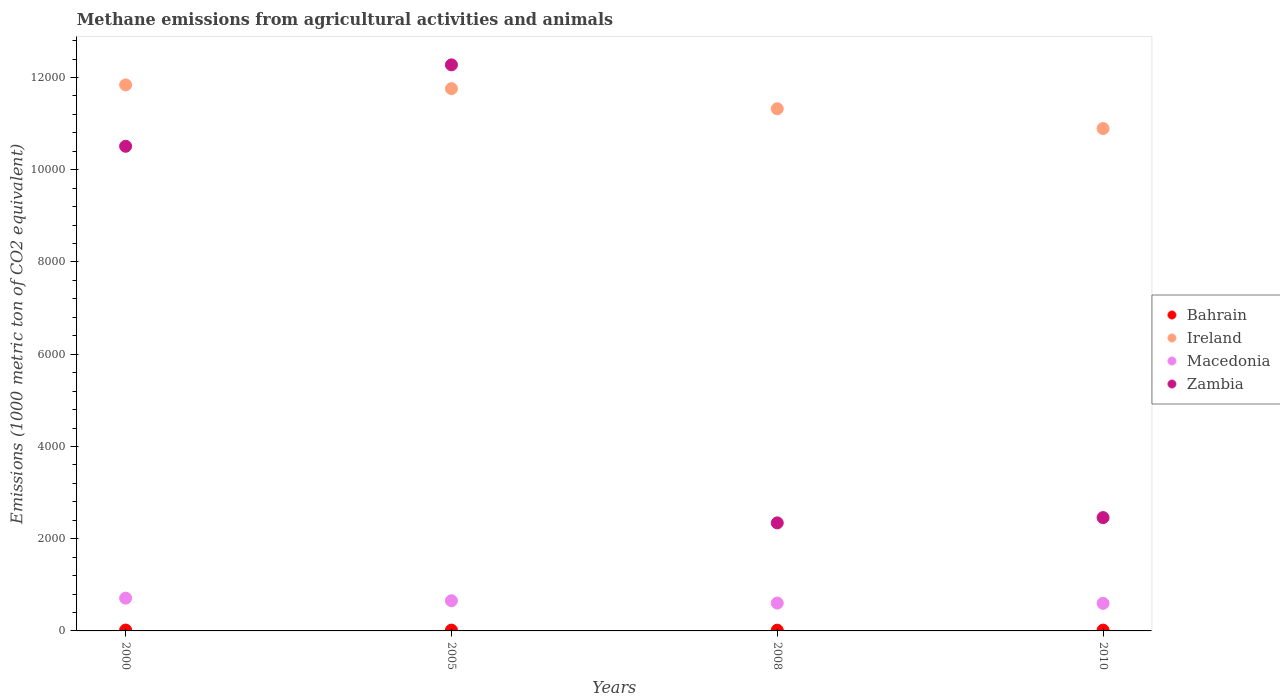How many different coloured dotlines are there?
Ensure brevity in your answer.  4. Is the number of dotlines equal to the number of legend labels?
Offer a very short reply. Yes. What is the amount of methane emitted in Ireland in 2008?
Offer a very short reply. 1.13e+04. Across all years, what is the maximum amount of methane emitted in Macedonia?
Provide a succinct answer. 710.8. What is the total amount of methane emitted in Bahrain in the graph?
Your answer should be very brief. 69.9. What is the difference between the amount of methane emitted in Bahrain in 2000 and that in 2008?
Keep it short and to the point. 2.3. What is the difference between the amount of methane emitted in Zambia in 2000 and the amount of methane emitted in Bahrain in 2010?
Provide a short and direct response. 1.05e+04. What is the average amount of methane emitted in Macedonia per year?
Ensure brevity in your answer.  641.83. In the year 2008, what is the difference between the amount of methane emitted in Ireland and amount of methane emitted in Macedonia?
Your answer should be compact. 1.07e+04. What is the ratio of the amount of methane emitted in Ireland in 2000 to that in 2010?
Keep it short and to the point. 1.09. Is the difference between the amount of methane emitted in Ireland in 2000 and 2010 greater than the difference between the amount of methane emitted in Macedonia in 2000 and 2010?
Your answer should be compact. Yes. What is the difference between the highest and the second highest amount of methane emitted in Macedonia?
Offer a very short reply. 56.4. What is the difference between the highest and the lowest amount of methane emitted in Bahrain?
Your answer should be very brief. 2.3. Is the sum of the amount of methane emitted in Bahrain in 2008 and 2010 greater than the maximum amount of methane emitted in Ireland across all years?
Offer a terse response. No. Is it the case that in every year, the sum of the amount of methane emitted in Zambia and amount of methane emitted in Macedonia  is greater than the amount of methane emitted in Ireland?
Provide a short and direct response. No. Does the amount of methane emitted in Zambia monotonically increase over the years?
Provide a short and direct response. No. Is the amount of methane emitted in Ireland strictly less than the amount of methane emitted in Macedonia over the years?
Offer a very short reply. No. What is the difference between two consecutive major ticks on the Y-axis?
Ensure brevity in your answer.  2000. Does the graph contain grids?
Give a very brief answer. No. Where does the legend appear in the graph?
Make the answer very short. Center right. What is the title of the graph?
Your answer should be very brief. Methane emissions from agricultural activities and animals. What is the label or title of the Y-axis?
Your answer should be very brief. Emissions (1000 metric ton of CO2 equivalent). What is the Emissions (1000 metric ton of CO2 equivalent) of Bahrain in 2000?
Provide a short and direct response. 18.5. What is the Emissions (1000 metric ton of CO2 equivalent) of Ireland in 2000?
Your response must be concise. 1.18e+04. What is the Emissions (1000 metric ton of CO2 equivalent) in Macedonia in 2000?
Keep it short and to the point. 710.8. What is the Emissions (1000 metric ton of CO2 equivalent) in Zambia in 2000?
Make the answer very short. 1.05e+04. What is the Emissions (1000 metric ton of CO2 equivalent) in Bahrain in 2005?
Give a very brief answer. 17.5. What is the Emissions (1000 metric ton of CO2 equivalent) in Ireland in 2005?
Your answer should be very brief. 1.18e+04. What is the Emissions (1000 metric ton of CO2 equivalent) in Macedonia in 2005?
Keep it short and to the point. 654.4. What is the Emissions (1000 metric ton of CO2 equivalent) in Zambia in 2005?
Give a very brief answer. 1.23e+04. What is the Emissions (1000 metric ton of CO2 equivalent) in Bahrain in 2008?
Make the answer very short. 16.2. What is the Emissions (1000 metric ton of CO2 equivalent) in Ireland in 2008?
Your answer should be compact. 1.13e+04. What is the Emissions (1000 metric ton of CO2 equivalent) in Macedonia in 2008?
Keep it short and to the point. 603.9. What is the Emissions (1000 metric ton of CO2 equivalent) of Zambia in 2008?
Keep it short and to the point. 2342.5. What is the Emissions (1000 metric ton of CO2 equivalent) of Bahrain in 2010?
Your answer should be compact. 17.7. What is the Emissions (1000 metric ton of CO2 equivalent) of Ireland in 2010?
Offer a terse response. 1.09e+04. What is the Emissions (1000 metric ton of CO2 equivalent) in Macedonia in 2010?
Provide a short and direct response. 598.2. What is the Emissions (1000 metric ton of CO2 equivalent) in Zambia in 2010?
Offer a terse response. 2457.2. Across all years, what is the maximum Emissions (1000 metric ton of CO2 equivalent) in Ireland?
Your answer should be very brief. 1.18e+04. Across all years, what is the maximum Emissions (1000 metric ton of CO2 equivalent) of Macedonia?
Keep it short and to the point. 710.8. Across all years, what is the maximum Emissions (1000 metric ton of CO2 equivalent) in Zambia?
Your answer should be very brief. 1.23e+04. Across all years, what is the minimum Emissions (1000 metric ton of CO2 equivalent) of Ireland?
Ensure brevity in your answer.  1.09e+04. Across all years, what is the minimum Emissions (1000 metric ton of CO2 equivalent) in Macedonia?
Your answer should be compact. 598.2. Across all years, what is the minimum Emissions (1000 metric ton of CO2 equivalent) in Zambia?
Ensure brevity in your answer.  2342.5. What is the total Emissions (1000 metric ton of CO2 equivalent) of Bahrain in the graph?
Provide a succinct answer. 69.9. What is the total Emissions (1000 metric ton of CO2 equivalent) of Ireland in the graph?
Provide a short and direct response. 4.58e+04. What is the total Emissions (1000 metric ton of CO2 equivalent) in Macedonia in the graph?
Keep it short and to the point. 2567.3. What is the total Emissions (1000 metric ton of CO2 equivalent) in Zambia in the graph?
Give a very brief answer. 2.76e+04. What is the difference between the Emissions (1000 metric ton of CO2 equivalent) of Ireland in 2000 and that in 2005?
Offer a terse response. 81.2. What is the difference between the Emissions (1000 metric ton of CO2 equivalent) in Macedonia in 2000 and that in 2005?
Provide a short and direct response. 56.4. What is the difference between the Emissions (1000 metric ton of CO2 equivalent) of Zambia in 2000 and that in 2005?
Make the answer very short. -1765.6. What is the difference between the Emissions (1000 metric ton of CO2 equivalent) in Bahrain in 2000 and that in 2008?
Offer a very short reply. 2.3. What is the difference between the Emissions (1000 metric ton of CO2 equivalent) in Ireland in 2000 and that in 2008?
Keep it short and to the point. 517.1. What is the difference between the Emissions (1000 metric ton of CO2 equivalent) of Macedonia in 2000 and that in 2008?
Your answer should be compact. 106.9. What is the difference between the Emissions (1000 metric ton of CO2 equivalent) of Zambia in 2000 and that in 2008?
Offer a terse response. 8166.4. What is the difference between the Emissions (1000 metric ton of CO2 equivalent) in Ireland in 2000 and that in 2010?
Your answer should be very brief. 946.6. What is the difference between the Emissions (1000 metric ton of CO2 equivalent) of Macedonia in 2000 and that in 2010?
Offer a very short reply. 112.6. What is the difference between the Emissions (1000 metric ton of CO2 equivalent) of Zambia in 2000 and that in 2010?
Offer a very short reply. 8051.7. What is the difference between the Emissions (1000 metric ton of CO2 equivalent) of Bahrain in 2005 and that in 2008?
Ensure brevity in your answer.  1.3. What is the difference between the Emissions (1000 metric ton of CO2 equivalent) in Ireland in 2005 and that in 2008?
Offer a terse response. 435.9. What is the difference between the Emissions (1000 metric ton of CO2 equivalent) in Macedonia in 2005 and that in 2008?
Offer a terse response. 50.5. What is the difference between the Emissions (1000 metric ton of CO2 equivalent) of Zambia in 2005 and that in 2008?
Make the answer very short. 9932. What is the difference between the Emissions (1000 metric ton of CO2 equivalent) in Ireland in 2005 and that in 2010?
Provide a succinct answer. 865.4. What is the difference between the Emissions (1000 metric ton of CO2 equivalent) of Macedonia in 2005 and that in 2010?
Your answer should be compact. 56.2. What is the difference between the Emissions (1000 metric ton of CO2 equivalent) of Zambia in 2005 and that in 2010?
Offer a very short reply. 9817.3. What is the difference between the Emissions (1000 metric ton of CO2 equivalent) of Ireland in 2008 and that in 2010?
Your response must be concise. 429.5. What is the difference between the Emissions (1000 metric ton of CO2 equivalent) in Zambia in 2008 and that in 2010?
Your answer should be compact. -114.7. What is the difference between the Emissions (1000 metric ton of CO2 equivalent) in Bahrain in 2000 and the Emissions (1000 metric ton of CO2 equivalent) in Ireland in 2005?
Your response must be concise. -1.17e+04. What is the difference between the Emissions (1000 metric ton of CO2 equivalent) in Bahrain in 2000 and the Emissions (1000 metric ton of CO2 equivalent) in Macedonia in 2005?
Offer a very short reply. -635.9. What is the difference between the Emissions (1000 metric ton of CO2 equivalent) in Bahrain in 2000 and the Emissions (1000 metric ton of CO2 equivalent) in Zambia in 2005?
Provide a succinct answer. -1.23e+04. What is the difference between the Emissions (1000 metric ton of CO2 equivalent) of Ireland in 2000 and the Emissions (1000 metric ton of CO2 equivalent) of Macedonia in 2005?
Provide a short and direct response. 1.12e+04. What is the difference between the Emissions (1000 metric ton of CO2 equivalent) in Ireland in 2000 and the Emissions (1000 metric ton of CO2 equivalent) in Zambia in 2005?
Give a very brief answer. -434.9. What is the difference between the Emissions (1000 metric ton of CO2 equivalent) of Macedonia in 2000 and the Emissions (1000 metric ton of CO2 equivalent) of Zambia in 2005?
Your answer should be very brief. -1.16e+04. What is the difference between the Emissions (1000 metric ton of CO2 equivalent) in Bahrain in 2000 and the Emissions (1000 metric ton of CO2 equivalent) in Ireland in 2008?
Make the answer very short. -1.13e+04. What is the difference between the Emissions (1000 metric ton of CO2 equivalent) of Bahrain in 2000 and the Emissions (1000 metric ton of CO2 equivalent) of Macedonia in 2008?
Your response must be concise. -585.4. What is the difference between the Emissions (1000 metric ton of CO2 equivalent) of Bahrain in 2000 and the Emissions (1000 metric ton of CO2 equivalent) of Zambia in 2008?
Provide a succinct answer. -2324. What is the difference between the Emissions (1000 metric ton of CO2 equivalent) of Ireland in 2000 and the Emissions (1000 metric ton of CO2 equivalent) of Macedonia in 2008?
Your answer should be very brief. 1.12e+04. What is the difference between the Emissions (1000 metric ton of CO2 equivalent) in Ireland in 2000 and the Emissions (1000 metric ton of CO2 equivalent) in Zambia in 2008?
Ensure brevity in your answer.  9497.1. What is the difference between the Emissions (1000 metric ton of CO2 equivalent) in Macedonia in 2000 and the Emissions (1000 metric ton of CO2 equivalent) in Zambia in 2008?
Keep it short and to the point. -1631.7. What is the difference between the Emissions (1000 metric ton of CO2 equivalent) of Bahrain in 2000 and the Emissions (1000 metric ton of CO2 equivalent) of Ireland in 2010?
Ensure brevity in your answer.  -1.09e+04. What is the difference between the Emissions (1000 metric ton of CO2 equivalent) of Bahrain in 2000 and the Emissions (1000 metric ton of CO2 equivalent) of Macedonia in 2010?
Offer a very short reply. -579.7. What is the difference between the Emissions (1000 metric ton of CO2 equivalent) of Bahrain in 2000 and the Emissions (1000 metric ton of CO2 equivalent) of Zambia in 2010?
Your response must be concise. -2438.7. What is the difference between the Emissions (1000 metric ton of CO2 equivalent) of Ireland in 2000 and the Emissions (1000 metric ton of CO2 equivalent) of Macedonia in 2010?
Offer a terse response. 1.12e+04. What is the difference between the Emissions (1000 metric ton of CO2 equivalent) in Ireland in 2000 and the Emissions (1000 metric ton of CO2 equivalent) in Zambia in 2010?
Make the answer very short. 9382.4. What is the difference between the Emissions (1000 metric ton of CO2 equivalent) of Macedonia in 2000 and the Emissions (1000 metric ton of CO2 equivalent) of Zambia in 2010?
Offer a terse response. -1746.4. What is the difference between the Emissions (1000 metric ton of CO2 equivalent) of Bahrain in 2005 and the Emissions (1000 metric ton of CO2 equivalent) of Ireland in 2008?
Your response must be concise. -1.13e+04. What is the difference between the Emissions (1000 metric ton of CO2 equivalent) in Bahrain in 2005 and the Emissions (1000 metric ton of CO2 equivalent) in Macedonia in 2008?
Give a very brief answer. -586.4. What is the difference between the Emissions (1000 metric ton of CO2 equivalent) of Bahrain in 2005 and the Emissions (1000 metric ton of CO2 equivalent) of Zambia in 2008?
Give a very brief answer. -2325. What is the difference between the Emissions (1000 metric ton of CO2 equivalent) of Ireland in 2005 and the Emissions (1000 metric ton of CO2 equivalent) of Macedonia in 2008?
Your answer should be very brief. 1.12e+04. What is the difference between the Emissions (1000 metric ton of CO2 equivalent) of Ireland in 2005 and the Emissions (1000 metric ton of CO2 equivalent) of Zambia in 2008?
Offer a very short reply. 9415.9. What is the difference between the Emissions (1000 metric ton of CO2 equivalent) of Macedonia in 2005 and the Emissions (1000 metric ton of CO2 equivalent) of Zambia in 2008?
Your answer should be very brief. -1688.1. What is the difference between the Emissions (1000 metric ton of CO2 equivalent) in Bahrain in 2005 and the Emissions (1000 metric ton of CO2 equivalent) in Ireland in 2010?
Your response must be concise. -1.09e+04. What is the difference between the Emissions (1000 metric ton of CO2 equivalent) in Bahrain in 2005 and the Emissions (1000 metric ton of CO2 equivalent) in Macedonia in 2010?
Keep it short and to the point. -580.7. What is the difference between the Emissions (1000 metric ton of CO2 equivalent) of Bahrain in 2005 and the Emissions (1000 metric ton of CO2 equivalent) of Zambia in 2010?
Give a very brief answer. -2439.7. What is the difference between the Emissions (1000 metric ton of CO2 equivalent) of Ireland in 2005 and the Emissions (1000 metric ton of CO2 equivalent) of Macedonia in 2010?
Provide a short and direct response. 1.12e+04. What is the difference between the Emissions (1000 metric ton of CO2 equivalent) in Ireland in 2005 and the Emissions (1000 metric ton of CO2 equivalent) in Zambia in 2010?
Offer a terse response. 9301.2. What is the difference between the Emissions (1000 metric ton of CO2 equivalent) of Macedonia in 2005 and the Emissions (1000 metric ton of CO2 equivalent) of Zambia in 2010?
Give a very brief answer. -1802.8. What is the difference between the Emissions (1000 metric ton of CO2 equivalent) of Bahrain in 2008 and the Emissions (1000 metric ton of CO2 equivalent) of Ireland in 2010?
Your answer should be compact. -1.09e+04. What is the difference between the Emissions (1000 metric ton of CO2 equivalent) of Bahrain in 2008 and the Emissions (1000 metric ton of CO2 equivalent) of Macedonia in 2010?
Give a very brief answer. -582. What is the difference between the Emissions (1000 metric ton of CO2 equivalent) of Bahrain in 2008 and the Emissions (1000 metric ton of CO2 equivalent) of Zambia in 2010?
Provide a short and direct response. -2441. What is the difference between the Emissions (1000 metric ton of CO2 equivalent) in Ireland in 2008 and the Emissions (1000 metric ton of CO2 equivalent) in Macedonia in 2010?
Provide a succinct answer. 1.07e+04. What is the difference between the Emissions (1000 metric ton of CO2 equivalent) of Ireland in 2008 and the Emissions (1000 metric ton of CO2 equivalent) of Zambia in 2010?
Your response must be concise. 8865.3. What is the difference between the Emissions (1000 metric ton of CO2 equivalent) in Macedonia in 2008 and the Emissions (1000 metric ton of CO2 equivalent) in Zambia in 2010?
Your answer should be very brief. -1853.3. What is the average Emissions (1000 metric ton of CO2 equivalent) in Bahrain per year?
Your answer should be compact. 17.48. What is the average Emissions (1000 metric ton of CO2 equivalent) in Ireland per year?
Provide a short and direct response. 1.15e+04. What is the average Emissions (1000 metric ton of CO2 equivalent) in Macedonia per year?
Ensure brevity in your answer.  641.83. What is the average Emissions (1000 metric ton of CO2 equivalent) of Zambia per year?
Provide a short and direct response. 6895.77. In the year 2000, what is the difference between the Emissions (1000 metric ton of CO2 equivalent) in Bahrain and Emissions (1000 metric ton of CO2 equivalent) in Ireland?
Provide a short and direct response. -1.18e+04. In the year 2000, what is the difference between the Emissions (1000 metric ton of CO2 equivalent) in Bahrain and Emissions (1000 metric ton of CO2 equivalent) in Macedonia?
Your response must be concise. -692.3. In the year 2000, what is the difference between the Emissions (1000 metric ton of CO2 equivalent) of Bahrain and Emissions (1000 metric ton of CO2 equivalent) of Zambia?
Keep it short and to the point. -1.05e+04. In the year 2000, what is the difference between the Emissions (1000 metric ton of CO2 equivalent) of Ireland and Emissions (1000 metric ton of CO2 equivalent) of Macedonia?
Give a very brief answer. 1.11e+04. In the year 2000, what is the difference between the Emissions (1000 metric ton of CO2 equivalent) in Ireland and Emissions (1000 metric ton of CO2 equivalent) in Zambia?
Give a very brief answer. 1330.7. In the year 2000, what is the difference between the Emissions (1000 metric ton of CO2 equivalent) of Macedonia and Emissions (1000 metric ton of CO2 equivalent) of Zambia?
Ensure brevity in your answer.  -9798.1. In the year 2005, what is the difference between the Emissions (1000 metric ton of CO2 equivalent) in Bahrain and Emissions (1000 metric ton of CO2 equivalent) in Ireland?
Make the answer very short. -1.17e+04. In the year 2005, what is the difference between the Emissions (1000 metric ton of CO2 equivalent) of Bahrain and Emissions (1000 metric ton of CO2 equivalent) of Macedonia?
Your answer should be very brief. -636.9. In the year 2005, what is the difference between the Emissions (1000 metric ton of CO2 equivalent) in Bahrain and Emissions (1000 metric ton of CO2 equivalent) in Zambia?
Your response must be concise. -1.23e+04. In the year 2005, what is the difference between the Emissions (1000 metric ton of CO2 equivalent) of Ireland and Emissions (1000 metric ton of CO2 equivalent) of Macedonia?
Your answer should be compact. 1.11e+04. In the year 2005, what is the difference between the Emissions (1000 metric ton of CO2 equivalent) of Ireland and Emissions (1000 metric ton of CO2 equivalent) of Zambia?
Give a very brief answer. -516.1. In the year 2005, what is the difference between the Emissions (1000 metric ton of CO2 equivalent) in Macedonia and Emissions (1000 metric ton of CO2 equivalent) in Zambia?
Ensure brevity in your answer.  -1.16e+04. In the year 2008, what is the difference between the Emissions (1000 metric ton of CO2 equivalent) of Bahrain and Emissions (1000 metric ton of CO2 equivalent) of Ireland?
Offer a very short reply. -1.13e+04. In the year 2008, what is the difference between the Emissions (1000 metric ton of CO2 equivalent) of Bahrain and Emissions (1000 metric ton of CO2 equivalent) of Macedonia?
Give a very brief answer. -587.7. In the year 2008, what is the difference between the Emissions (1000 metric ton of CO2 equivalent) in Bahrain and Emissions (1000 metric ton of CO2 equivalent) in Zambia?
Offer a terse response. -2326.3. In the year 2008, what is the difference between the Emissions (1000 metric ton of CO2 equivalent) in Ireland and Emissions (1000 metric ton of CO2 equivalent) in Macedonia?
Provide a short and direct response. 1.07e+04. In the year 2008, what is the difference between the Emissions (1000 metric ton of CO2 equivalent) in Ireland and Emissions (1000 metric ton of CO2 equivalent) in Zambia?
Give a very brief answer. 8980. In the year 2008, what is the difference between the Emissions (1000 metric ton of CO2 equivalent) in Macedonia and Emissions (1000 metric ton of CO2 equivalent) in Zambia?
Your response must be concise. -1738.6. In the year 2010, what is the difference between the Emissions (1000 metric ton of CO2 equivalent) of Bahrain and Emissions (1000 metric ton of CO2 equivalent) of Ireland?
Ensure brevity in your answer.  -1.09e+04. In the year 2010, what is the difference between the Emissions (1000 metric ton of CO2 equivalent) of Bahrain and Emissions (1000 metric ton of CO2 equivalent) of Macedonia?
Your answer should be compact. -580.5. In the year 2010, what is the difference between the Emissions (1000 metric ton of CO2 equivalent) in Bahrain and Emissions (1000 metric ton of CO2 equivalent) in Zambia?
Ensure brevity in your answer.  -2439.5. In the year 2010, what is the difference between the Emissions (1000 metric ton of CO2 equivalent) of Ireland and Emissions (1000 metric ton of CO2 equivalent) of Macedonia?
Offer a terse response. 1.03e+04. In the year 2010, what is the difference between the Emissions (1000 metric ton of CO2 equivalent) of Ireland and Emissions (1000 metric ton of CO2 equivalent) of Zambia?
Make the answer very short. 8435.8. In the year 2010, what is the difference between the Emissions (1000 metric ton of CO2 equivalent) of Macedonia and Emissions (1000 metric ton of CO2 equivalent) of Zambia?
Make the answer very short. -1859. What is the ratio of the Emissions (1000 metric ton of CO2 equivalent) in Bahrain in 2000 to that in 2005?
Your response must be concise. 1.06. What is the ratio of the Emissions (1000 metric ton of CO2 equivalent) of Macedonia in 2000 to that in 2005?
Provide a succinct answer. 1.09. What is the ratio of the Emissions (1000 metric ton of CO2 equivalent) in Zambia in 2000 to that in 2005?
Offer a terse response. 0.86. What is the ratio of the Emissions (1000 metric ton of CO2 equivalent) in Bahrain in 2000 to that in 2008?
Provide a short and direct response. 1.14. What is the ratio of the Emissions (1000 metric ton of CO2 equivalent) of Ireland in 2000 to that in 2008?
Keep it short and to the point. 1.05. What is the ratio of the Emissions (1000 metric ton of CO2 equivalent) of Macedonia in 2000 to that in 2008?
Your answer should be compact. 1.18. What is the ratio of the Emissions (1000 metric ton of CO2 equivalent) of Zambia in 2000 to that in 2008?
Your answer should be very brief. 4.49. What is the ratio of the Emissions (1000 metric ton of CO2 equivalent) in Bahrain in 2000 to that in 2010?
Ensure brevity in your answer.  1.05. What is the ratio of the Emissions (1000 metric ton of CO2 equivalent) of Ireland in 2000 to that in 2010?
Offer a terse response. 1.09. What is the ratio of the Emissions (1000 metric ton of CO2 equivalent) in Macedonia in 2000 to that in 2010?
Your answer should be very brief. 1.19. What is the ratio of the Emissions (1000 metric ton of CO2 equivalent) of Zambia in 2000 to that in 2010?
Your answer should be very brief. 4.28. What is the ratio of the Emissions (1000 metric ton of CO2 equivalent) in Bahrain in 2005 to that in 2008?
Offer a terse response. 1.08. What is the ratio of the Emissions (1000 metric ton of CO2 equivalent) of Ireland in 2005 to that in 2008?
Offer a terse response. 1.04. What is the ratio of the Emissions (1000 metric ton of CO2 equivalent) in Macedonia in 2005 to that in 2008?
Your response must be concise. 1.08. What is the ratio of the Emissions (1000 metric ton of CO2 equivalent) in Zambia in 2005 to that in 2008?
Your answer should be compact. 5.24. What is the ratio of the Emissions (1000 metric ton of CO2 equivalent) in Bahrain in 2005 to that in 2010?
Give a very brief answer. 0.99. What is the ratio of the Emissions (1000 metric ton of CO2 equivalent) of Ireland in 2005 to that in 2010?
Ensure brevity in your answer.  1.08. What is the ratio of the Emissions (1000 metric ton of CO2 equivalent) of Macedonia in 2005 to that in 2010?
Provide a succinct answer. 1.09. What is the ratio of the Emissions (1000 metric ton of CO2 equivalent) of Zambia in 2005 to that in 2010?
Your answer should be compact. 5. What is the ratio of the Emissions (1000 metric ton of CO2 equivalent) in Bahrain in 2008 to that in 2010?
Offer a terse response. 0.92. What is the ratio of the Emissions (1000 metric ton of CO2 equivalent) of Ireland in 2008 to that in 2010?
Offer a terse response. 1.04. What is the ratio of the Emissions (1000 metric ton of CO2 equivalent) in Macedonia in 2008 to that in 2010?
Your response must be concise. 1.01. What is the ratio of the Emissions (1000 metric ton of CO2 equivalent) in Zambia in 2008 to that in 2010?
Your answer should be very brief. 0.95. What is the difference between the highest and the second highest Emissions (1000 metric ton of CO2 equivalent) of Ireland?
Offer a very short reply. 81.2. What is the difference between the highest and the second highest Emissions (1000 metric ton of CO2 equivalent) of Macedonia?
Give a very brief answer. 56.4. What is the difference between the highest and the second highest Emissions (1000 metric ton of CO2 equivalent) of Zambia?
Provide a succinct answer. 1765.6. What is the difference between the highest and the lowest Emissions (1000 metric ton of CO2 equivalent) in Ireland?
Give a very brief answer. 946.6. What is the difference between the highest and the lowest Emissions (1000 metric ton of CO2 equivalent) in Macedonia?
Provide a short and direct response. 112.6. What is the difference between the highest and the lowest Emissions (1000 metric ton of CO2 equivalent) in Zambia?
Keep it short and to the point. 9932. 